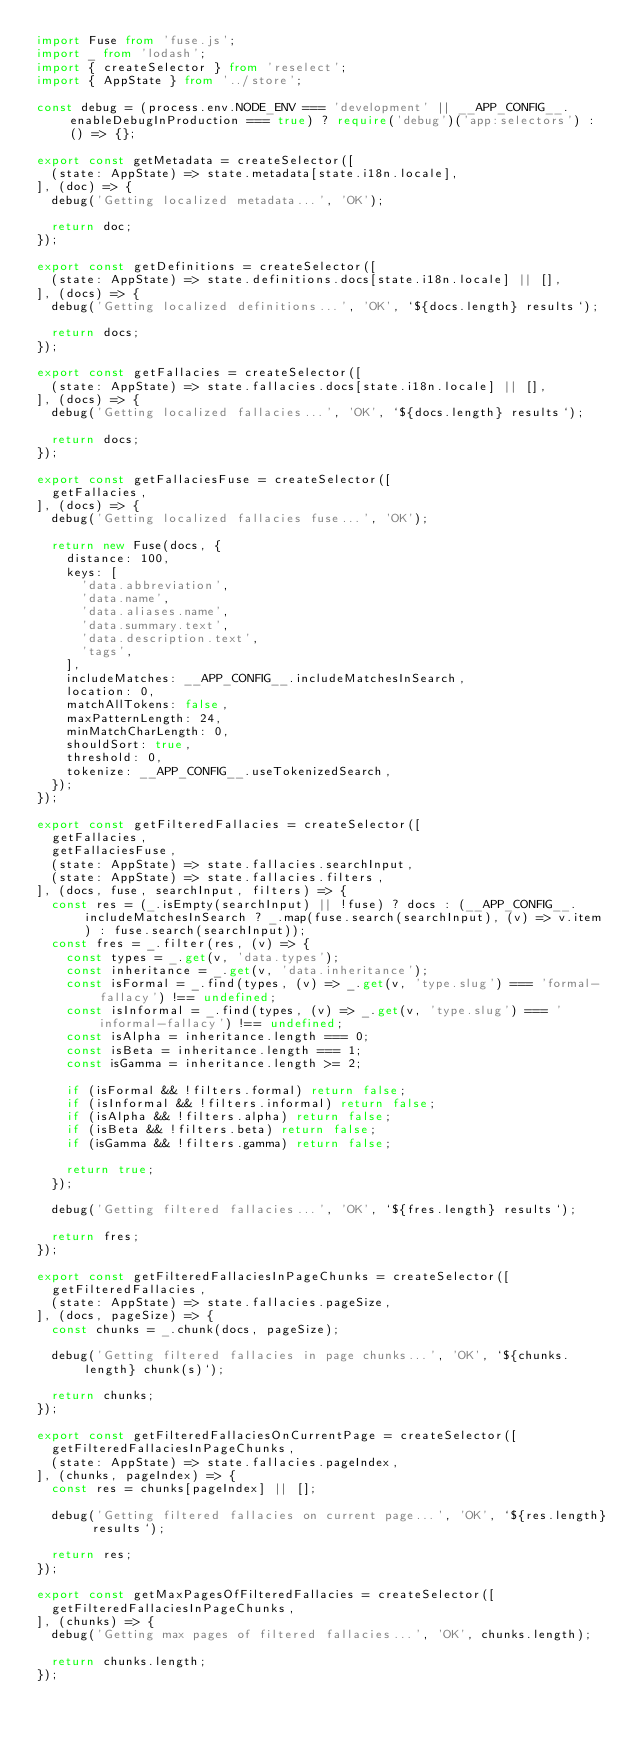<code> <loc_0><loc_0><loc_500><loc_500><_TypeScript_>import Fuse from 'fuse.js';
import _ from 'lodash';
import { createSelector } from 'reselect';
import { AppState } from '../store';

const debug = (process.env.NODE_ENV === 'development' || __APP_CONFIG__.enableDebugInProduction === true) ? require('debug')('app:selectors') : () => {};

export const getMetadata = createSelector([
  (state: AppState) => state.metadata[state.i18n.locale],
], (doc) => {
  debug('Getting localized metadata...', 'OK');

  return doc;
});

export const getDefinitions = createSelector([
  (state: AppState) => state.definitions.docs[state.i18n.locale] || [],
], (docs) => {
  debug('Getting localized definitions...', 'OK', `${docs.length} results`);

  return docs;
});

export const getFallacies = createSelector([
  (state: AppState) => state.fallacies.docs[state.i18n.locale] || [],
], (docs) => {
  debug('Getting localized fallacies...', 'OK', `${docs.length} results`);

  return docs;
});

export const getFallaciesFuse = createSelector([
  getFallacies,
], (docs) => {
  debug('Getting localized fallacies fuse...', 'OK');

  return new Fuse(docs, {
    distance: 100,
    keys: [
      'data.abbreviation',
      'data.name',
      'data.aliases.name',
      'data.summary.text',
      'data.description.text',
      'tags',
    ],
    includeMatches: __APP_CONFIG__.includeMatchesInSearch,
    location: 0,
    matchAllTokens: false,
    maxPatternLength: 24,
    minMatchCharLength: 0,
    shouldSort: true,
    threshold: 0,
    tokenize: __APP_CONFIG__.useTokenizedSearch,
  });
});

export const getFilteredFallacies = createSelector([
  getFallacies,
  getFallaciesFuse,
  (state: AppState) => state.fallacies.searchInput,
  (state: AppState) => state.fallacies.filters,
], (docs, fuse, searchInput, filters) => {
  const res = (_.isEmpty(searchInput) || !fuse) ? docs : (__APP_CONFIG__.includeMatchesInSearch ? _.map(fuse.search(searchInput), (v) => v.item) : fuse.search(searchInput));
  const fres = _.filter(res, (v) => {
    const types = _.get(v, 'data.types');
    const inheritance = _.get(v, 'data.inheritance');
    const isFormal = _.find(types, (v) => _.get(v, 'type.slug') === 'formal-fallacy') !== undefined;
    const isInformal = _.find(types, (v) => _.get(v, 'type.slug') === 'informal-fallacy') !== undefined;
    const isAlpha = inheritance.length === 0;
    const isBeta = inheritance.length === 1;
    const isGamma = inheritance.length >= 2;

    if (isFormal && !filters.formal) return false;
    if (isInformal && !filters.informal) return false;
    if (isAlpha && !filters.alpha) return false;
    if (isBeta && !filters.beta) return false;
    if (isGamma && !filters.gamma) return false;

    return true;
  });

  debug('Getting filtered fallacies...', 'OK', `${fres.length} results`);

  return fres;
});

export const getFilteredFallaciesInPageChunks = createSelector([
  getFilteredFallacies,
  (state: AppState) => state.fallacies.pageSize,
], (docs, pageSize) => {
  const chunks = _.chunk(docs, pageSize);

  debug('Getting filtered fallacies in page chunks...', 'OK', `${chunks.length} chunk(s)`);

  return chunks;
});

export const getFilteredFallaciesOnCurrentPage = createSelector([
  getFilteredFallaciesInPageChunks,
  (state: AppState) => state.fallacies.pageIndex,
], (chunks, pageIndex) => {
  const res = chunks[pageIndex] || [];

  debug('Getting filtered fallacies on current page...', 'OK', `${res.length} results`);

  return res;
});

export const getMaxPagesOfFilteredFallacies = createSelector([
  getFilteredFallaciesInPageChunks,
], (chunks) => {
  debug('Getting max pages of filtered fallacies...', 'OK', chunks.length);

  return chunks.length;
});
</code> 